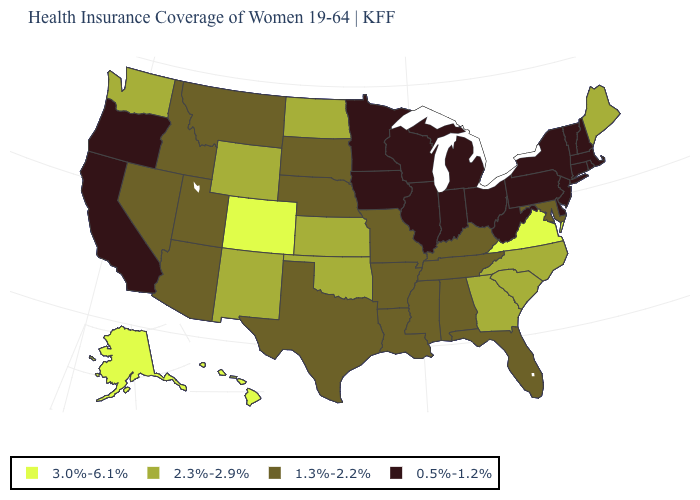Name the states that have a value in the range 0.5%-1.2%?
Answer briefly. California, Connecticut, Delaware, Illinois, Indiana, Iowa, Massachusetts, Michigan, Minnesota, New Hampshire, New Jersey, New York, Ohio, Oregon, Pennsylvania, Rhode Island, Vermont, West Virginia, Wisconsin. Is the legend a continuous bar?
Keep it brief. No. What is the value of North Carolina?
Quick response, please. 2.3%-2.9%. Name the states that have a value in the range 3.0%-6.1%?
Answer briefly. Alaska, Colorado, Hawaii, Virginia. Does Missouri have the lowest value in the USA?
Quick response, please. No. What is the value of Wisconsin?
Give a very brief answer. 0.5%-1.2%. Does New York have the lowest value in the USA?
Give a very brief answer. Yes. Does the first symbol in the legend represent the smallest category?
Short answer required. No. What is the value of Kansas?
Answer briefly. 2.3%-2.9%. What is the highest value in the USA?
Concise answer only. 3.0%-6.1%. Does the first symbol in the legend represent the smallest category?
Be succinct. No. Which states have the lowest value in the USA?
Quick response, please. California, Connecticut, Delaware, Illinois, Indiana, Iowa, Massachusetts, Michigan, Minnesota, New Hampshire, New Jersey, New York, Ohio, Oregon, Pennsylvania, Rhode Island, Vermont, West Virginia, Wisconsin. What is the lowest value in the South?
Quick response, please. 0.5%-1.2%. Which states hav the highest value in the MidWest?
Give a very brief answer. Kansas, North Dakota. What is the value of Oregon?
Give a very brief answer. 0.5%-1.2%. 